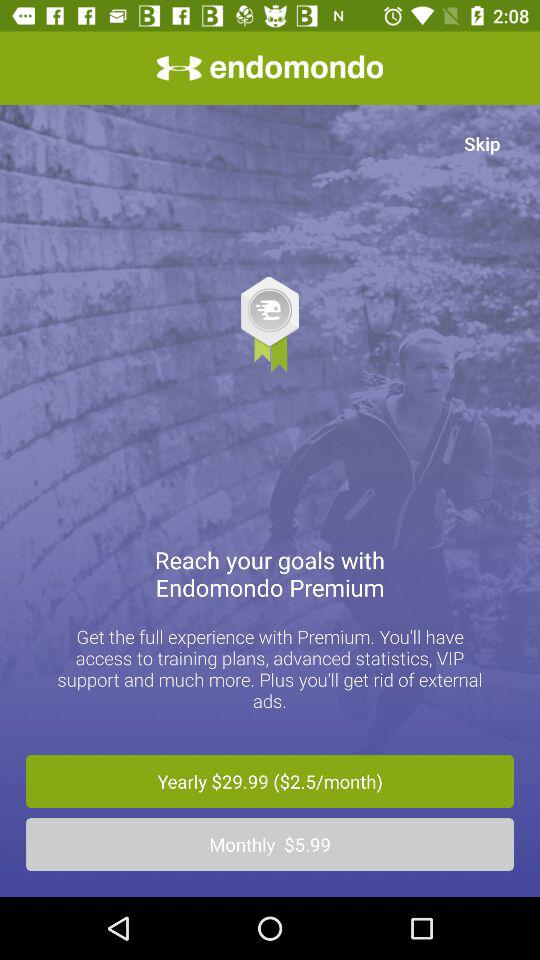What is the monthly charge for the plan? The monthly charge for the plan is $5.99. 